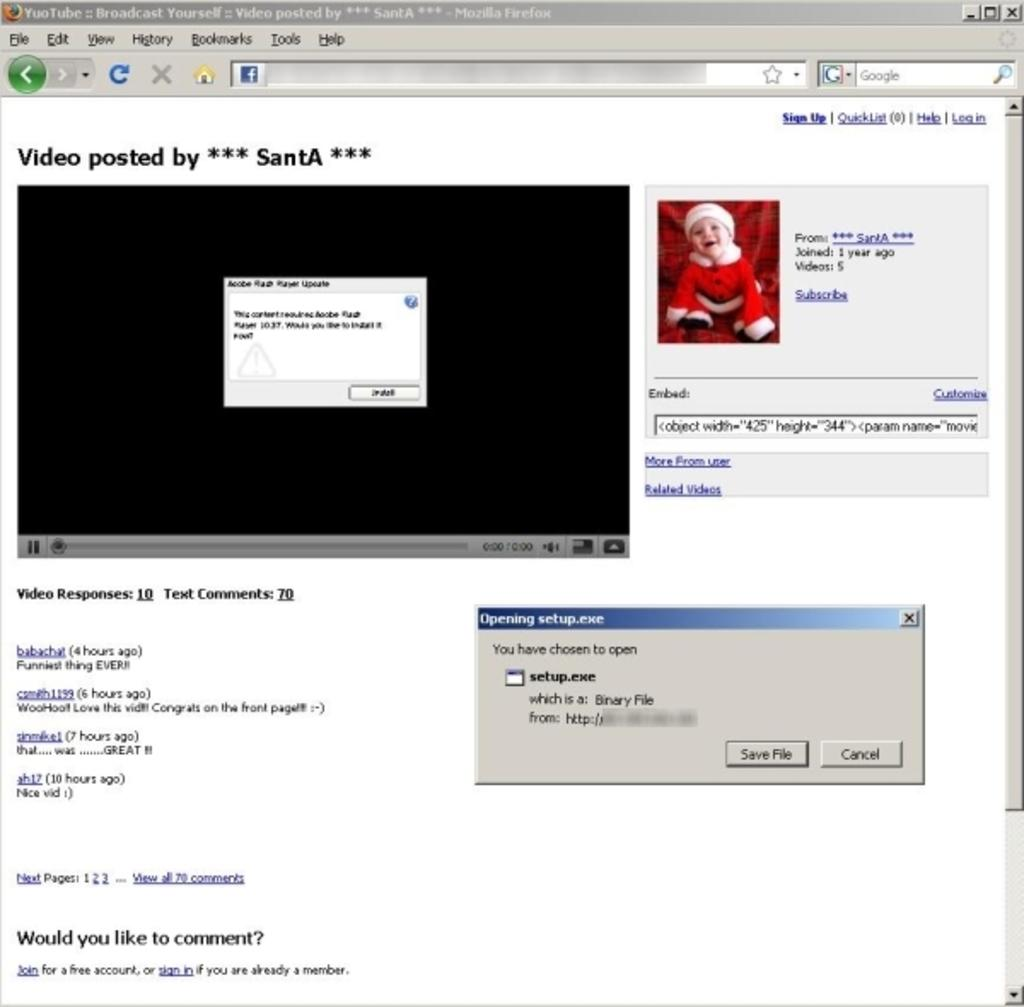<image>
Share a concise interpretation of the image provided. A computer screen is showing a video that was posted by Santa. 